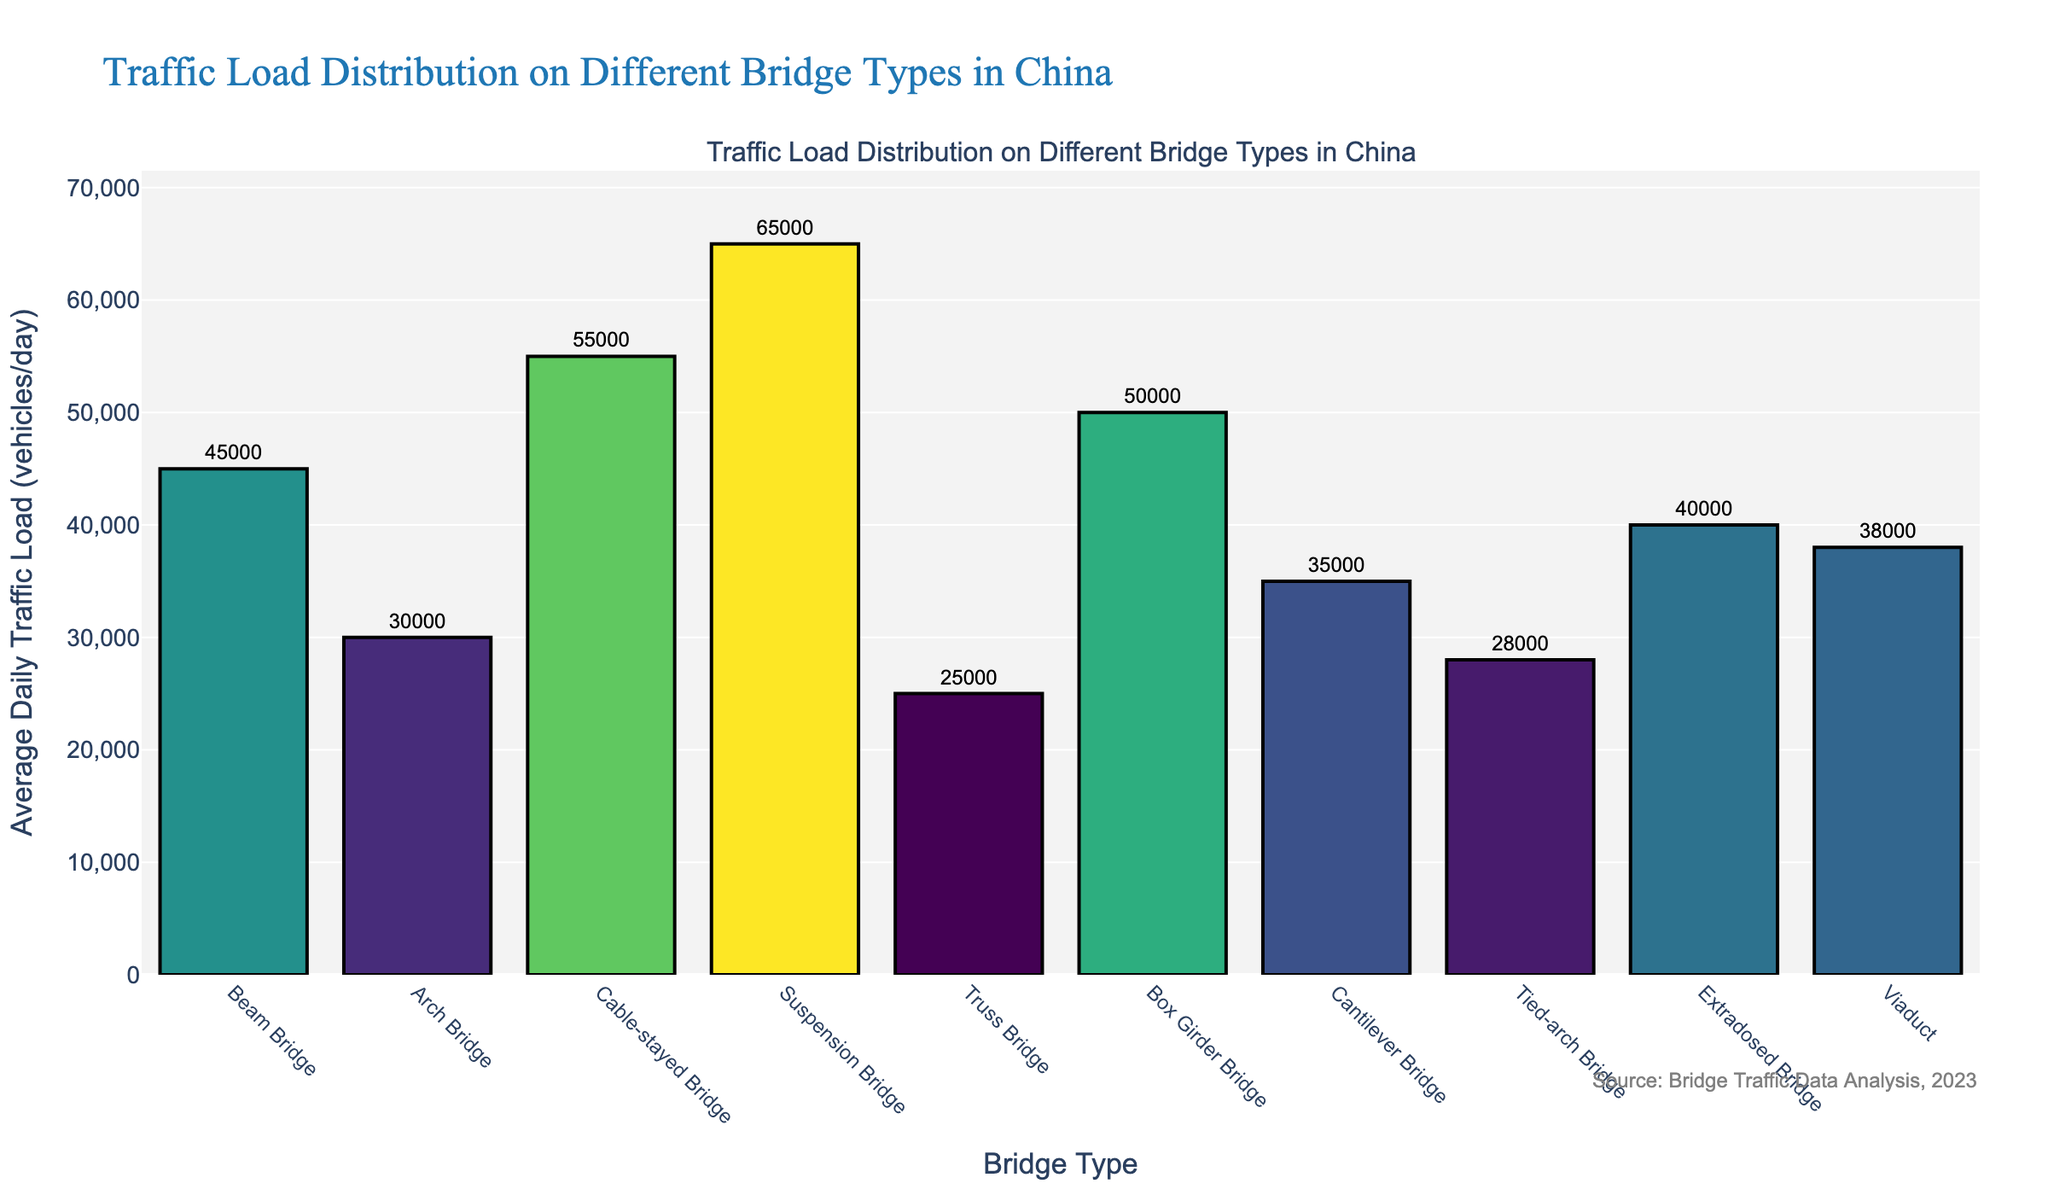Which bridge type has the highest average daily traffic load? The bar representing the Suspension Bridge towers the tallest among all, indicating it has the highest load.
Answer: Suspension Bridge Which bridge type has a lower average daily traffic load than the Box Girder Bridge, but higher than the Arch Bridge? The average daily traffic load of the Box Girder Bridge is higher compared to the Viaduct, while Cantilever Bridge has a load higher than the Arch Bridge but lower than the Box Girder Bridge.
Answer: Cantilever Bridge What is the sum of the average daily traffic load of Beam Bridge and Cable-stayed Bridge? The load for Beam Bridge is 45,000 vehicles/day and for Cable-stayed Bridge is 55,000 vehicles/day, thus their sum is 100,000 vehicles/day.
Answer: 100,000 Which bridge type has the smallest average daily traffic load? The bar representing the Truss Bridge is the shortest among all, indicating it has the smallest load.
Answer: Truss Bridge What is the difference in average daily traffic load between Suspension Bridge and Arch Bridge? The average daily traffic load for Suspension Bridge is 65,000 vehicles/day and for Arch Bridge, it is 30,000 vehicles/day. Their difference is 35,000 vehicles/day.
Answer: 35,000 